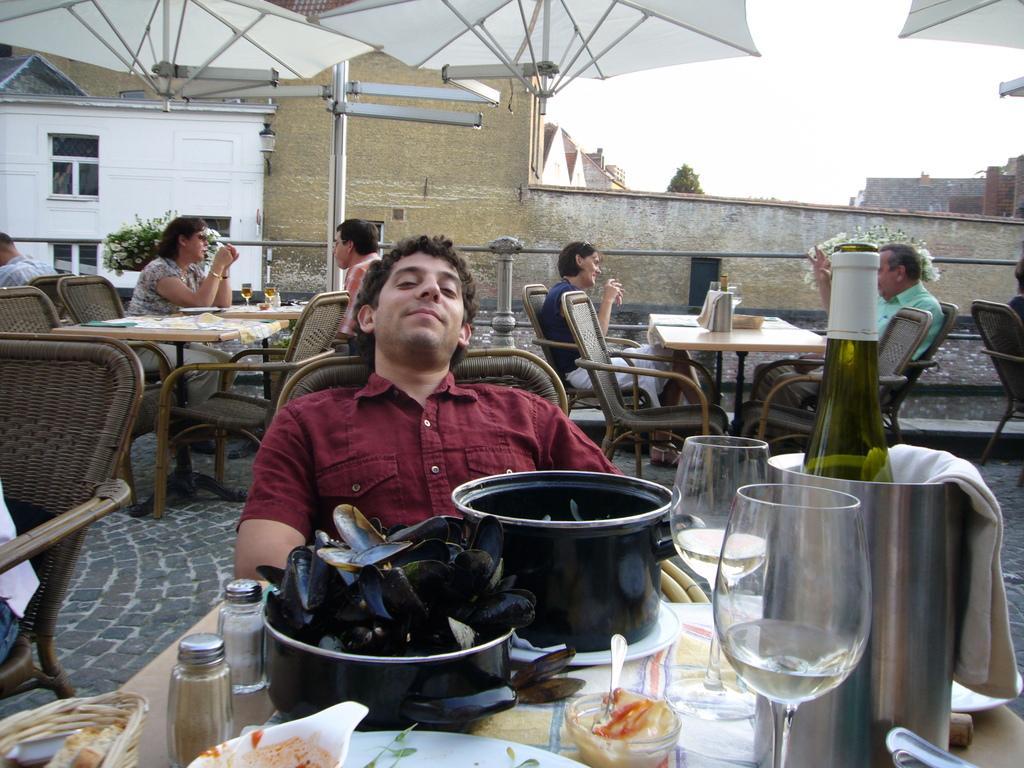In one or two sentences, can you explain what this image depicts? The person wearing red dress is sitting in a chair and there are some eatables and drinks in front of him and there are group of people and buildings in the background. 